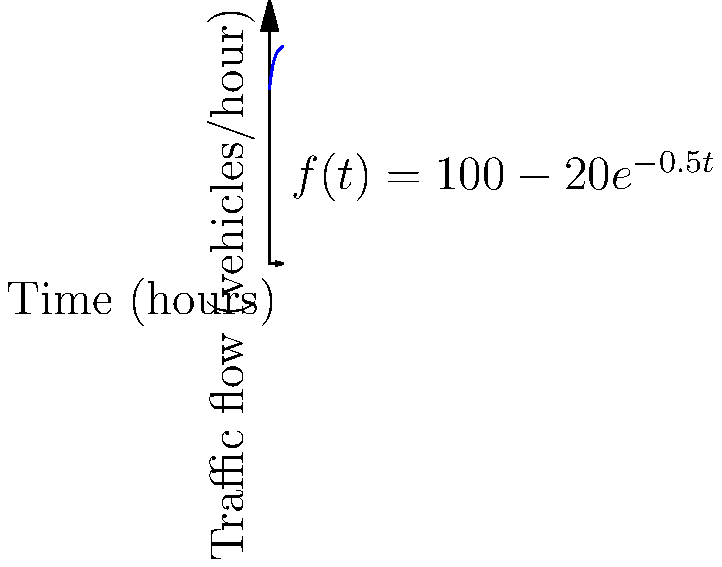The graph represents the traffic flow through a sobriety checkpoint over time. The function $f(t) = 100 - 20e^{-0.5t}$ models the number of vehicles passing through the checkpoint per hour, where $t$ is the time in hours since the checkpoint was established. At what rate is the traffic flow changing after 2 hours? To find the rate of change of traffic flow after 2 hours, we need to calculate the derivative of the function $f(t)$ and evaluate it at $t=2$. Here's the step-by-step process:

1) The given function is $f(t) = 100 - 20e^{-0.5t}$

2) To find the derivative, we use the chain rule:
   $f'(t) = -20 \cdot (-0.5) \cdot e^{-0.5t} = 10e^{-0.5t}$

3) Now we evaluate $f'(2)$:
   $f'(2) = 10e^{-0.5(2)} = 10e^{-1} \approx 3.68$

Therefore, after 2 hours, the traffic flow is changing at a rate of approximately 3.68 vehicles per hour per hour.
Answer: $3.68$ vehicles/hour² 